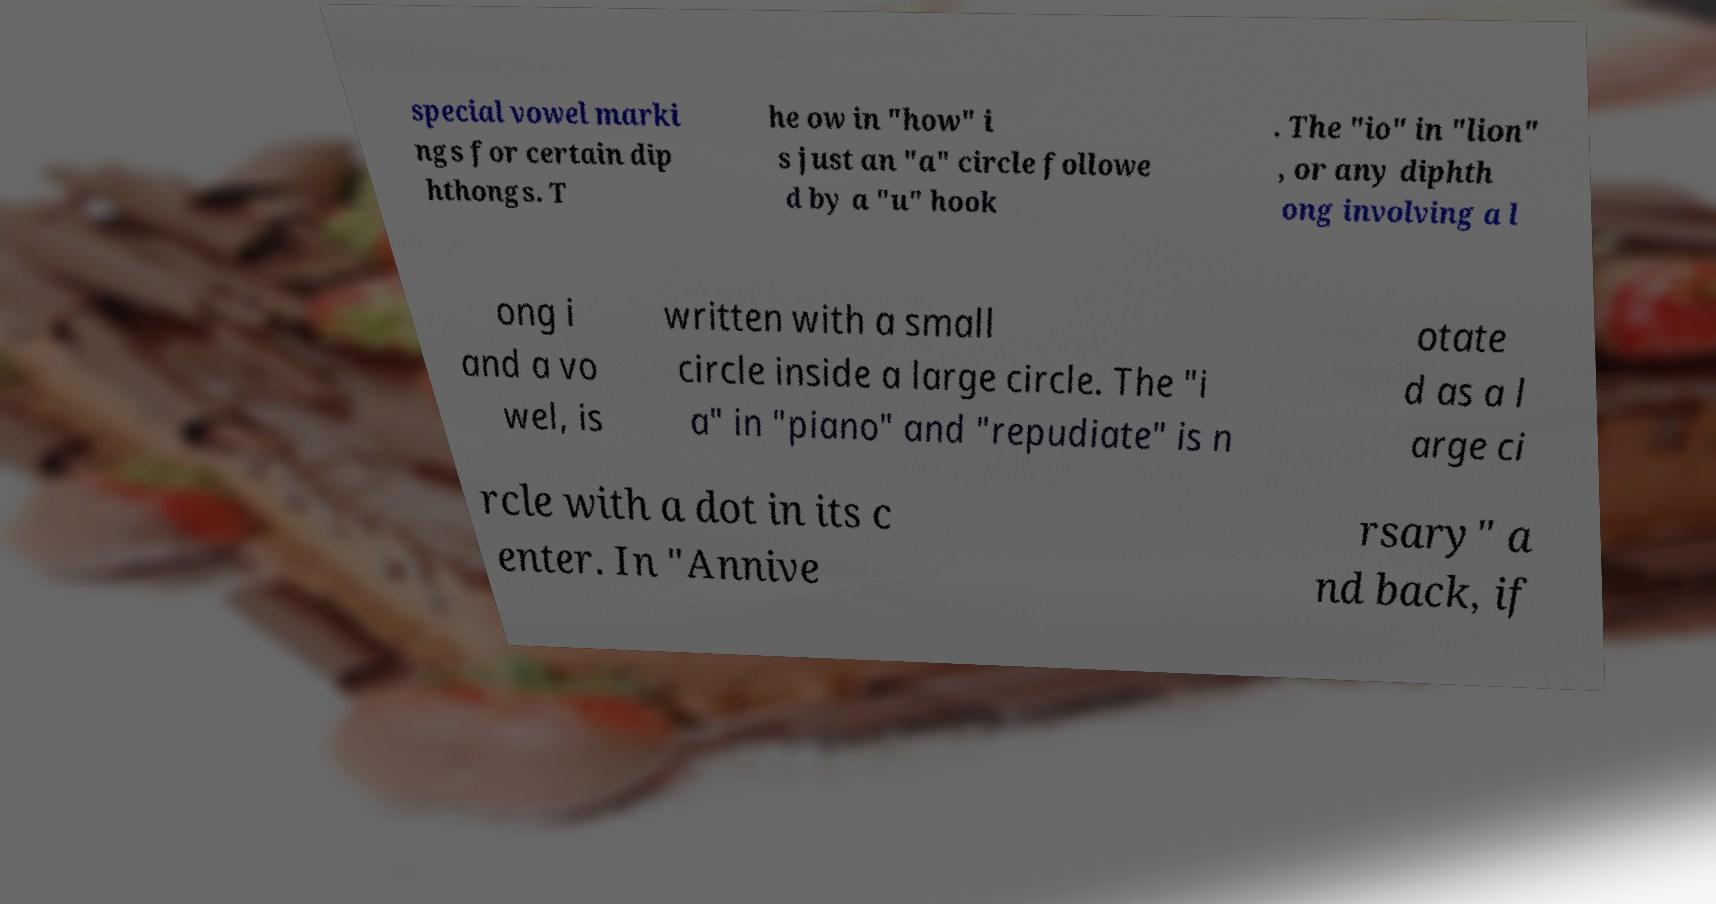Could you assist in decoding the text presented in this image and type it out clearly? special vowel marki ngs for certain dip hthongs. T he ow in "how" i s just an "a" circle followe d by a "u" hook . The "io" in "lion" , or any diphth ong involving a l ong i and a vo wel, is written with a small circle inside a large circle. The "i a" in "piano" and "repudiate" is n otate d as a l arge ci rcle with a dot in its c enter. In "Annive rsary" a nd back, if 